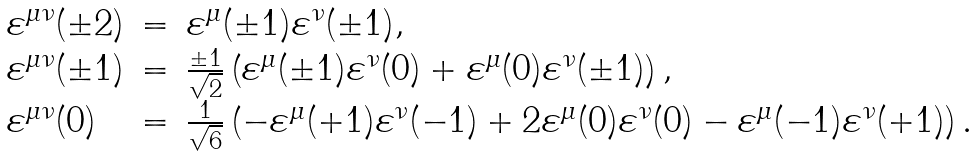Convert formula to latex. <formula><loc_0><loc_0><loc_500><loc_500>\begin{array} { l c l } \varepsilon ^ { \mu \nu } ( \pm 2 ) & = & \varepsilon ^ { \mu } ( \pm 1 ) \varepsilon ^ { \nu } ( \pm 1 ) , \\ \varepsilon ^ { \mu \nu } ( \pm 1 ) & = & \frac { \pm 1 } { \sqrt { 2 } } \left ( \varepsilon ^ { \mu } ( \pm 1 ) \varepsilon ^ { \nu } ( 0 ) + \varepsilon ^ { \mu } ( 0 ) \varepsilon ^ { \nu } ( \pm 1 ) \right ) , \\ \varepsilon ^ { \mu \nu } ( 0 ) & = & \frac { 1 } { \sqrt { 6 } } \left ( - \varepsilon ^ { \mu } ( + 1 ) \varepsilon ^ { \nu } ( - 1 ) + 2 \varepsilon ^ { \mu } ( 0 ) \varepsilon ^ { \nu } ( 0 ) - \varepsilon ^ { \mu } ( - 1 ) \varepsilon ^ { \nu } ( + 1 ) \right ) . \end{array}</formula> 